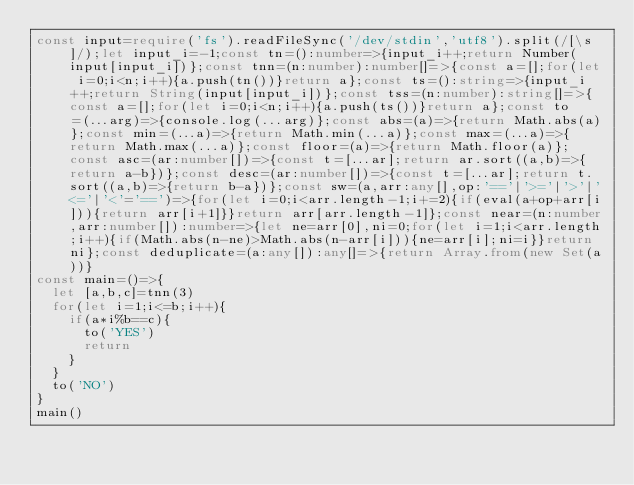<code> <loc_0><loc_0><loc_500><loc_500><_TypeScript_>const input=require('fs').readFileSync('/dev/stdin','utf8').split(/[\s]/);let input_i=-1;const tn=():number=>{input_i++;return Number(input[input_i])};const tnn=(n:number):number[]=>{const a=[];for(let i=0;i<n;i++){a.push(tn())}return a};const ts=():string=>{input_i++;return String(input[input_i])};const tss=(n:number):string[]=>{const a=[];for(let i=0;i<n;i++){a.push(ts())}return a};const to=(...arg)=>{console.log(...arg)};const abs=(a)=>{return Math.abs(a)};const min=(...a)=>{return Math.min(...a)};const max=(...a)=>{return Math.max(...a)};const floor=(a)=>{return Math.floor(a)};const asc=(ar:number[])=>{const t=[...ar];return ar.sort((a,b)=>{return a-b})};const desc=(ar:number[])=>{const t=[...ar];return t.sort((a,b)=>{return b-a})};const sw=(a,arr:any[],op:'=='|'>='|'>'|'<='|'<'='==')=>{for(let i=0;i<arr.length-1;i+=2){if(eval(a+op+arr[i])){return arr[i+1]}}return arr[arr.length-1]};const near=(n:number,arr:number[]):number=>{let ne=arr[0],ni=0;for(let i=1;i<arr.length;i++){if(Math.abs(n-ne)>Math.abs(n-arr[i])){ne=arr[i];ni=i}}return ni};const deduplicate=(a:any[]):any[]=>{return Array.from(new Set(a))}
const main=()=>{
  let [a,b,c]=tnn(3)
  for(let i=1;i<=b;i++){
    if(a*i%b==c){
      to('YES')
      return
    }
  }
  to('NO')
}
main()</code> 